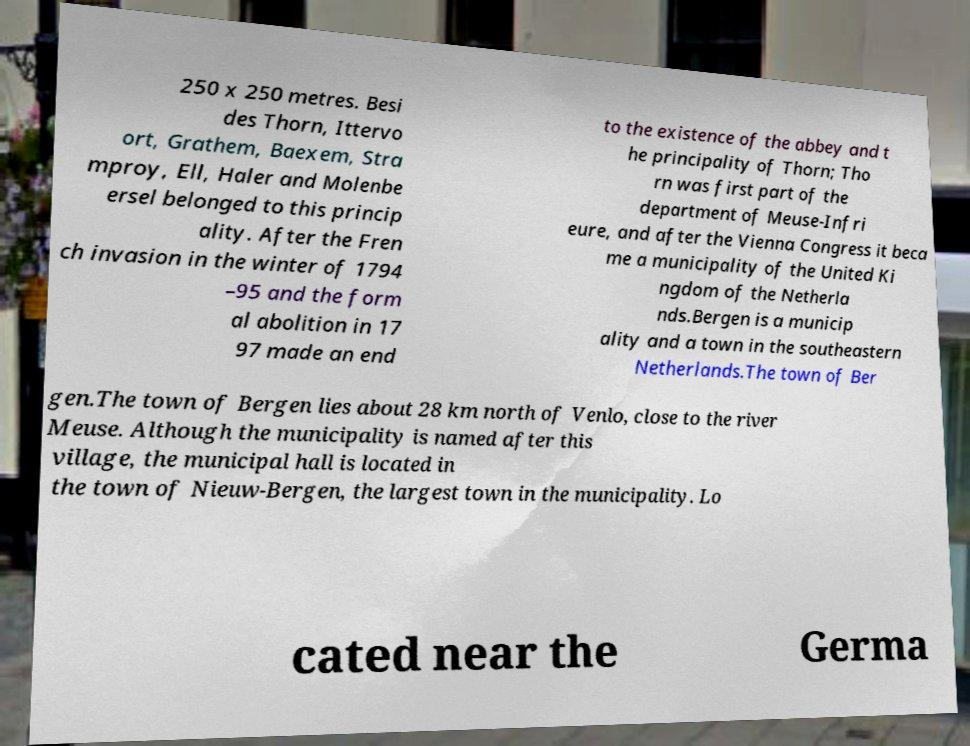There's text embedded in this image that I need extracted. Can you transcribe it verbatim? 250 x 250 metres. Besi des Thorn, Ittervo ort, Grathem, Baexem, Stra mproy, Ell, Haler and Molenbe ersel belonged to this princip ality. After the Fren ch invasion in the winter of 1794 –95 and the form al abolition in 17 97 made an end to the existence of the abbey and t he principality of Thorn; Tho rn was first part of the department of Meuse-Infri eure, and after the Vienna Congress it beca me a municipality of the United Ki ngdom of the Netherla nds.Bergen is a municip ality and a town in the southeastern Netherlands.The town of Ber gen.The town of Bergen lies about 28 km north of Venlo, close to the river Meuse. Although the municipality is named after this village, the municipal hall is located in the town of Nieuw-Bergen, the largest town in the municipality. Lo cated near the Germa 